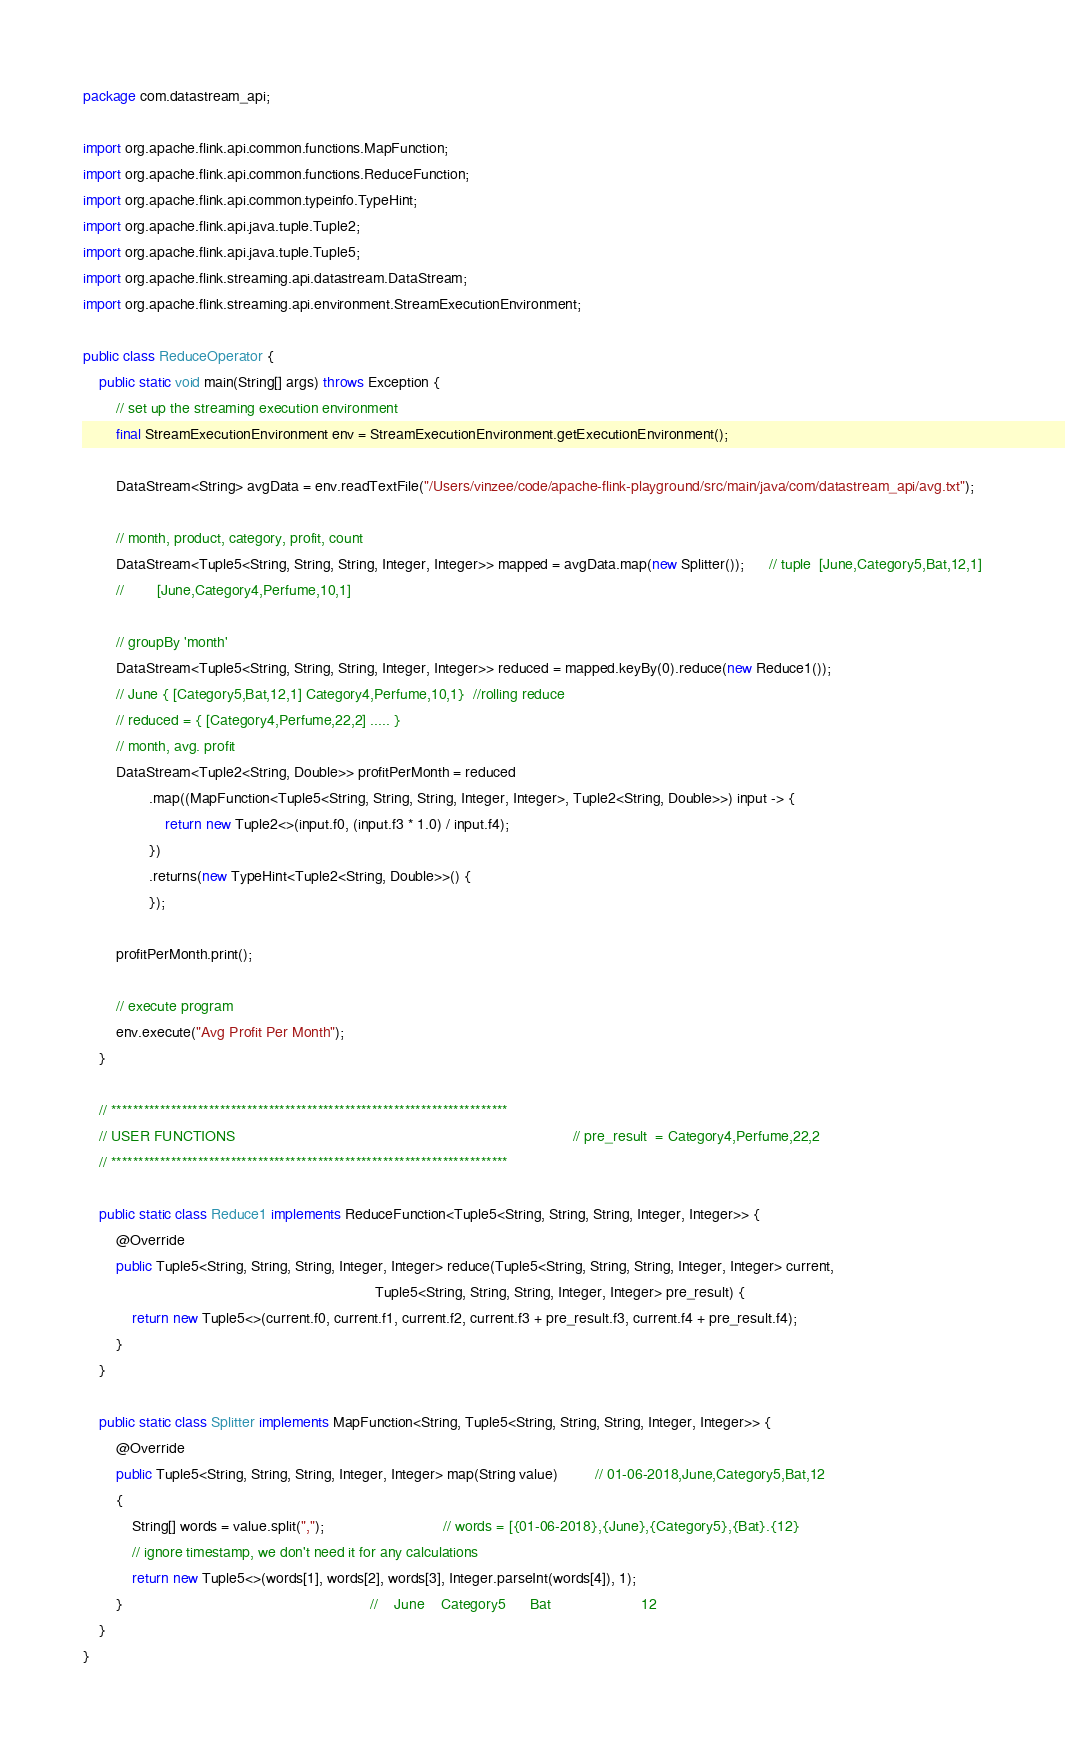Convert code to text. <code><loc_0><loc_0><loc_500><loc_500><_Java_>package com.datastream_api;

import org.apache.flink.api.common.functions.MapFunction;
import org.apache.flink.api.common.functions.ReduceFunction;
import org.apache.flink.api.common.typeinfo.TypeHint;
import org.apache.flink.api.java.tuple.Tuple2;
import org.apache.flink.api.java.tuple.Tuple5;
import org.apache.flink.streaming.api.datastream.DataStream;
import org.apache.flink.streaming.api.environment.StreamExecutionEnvironment;

public class ReduceOperator {
    public static void main(String[] args) throws Exception {
        // set up the streaming execution environment
        final StreamExecutionEnvironment env = StreamExecutionEnvironment.getExecutionEnvironment();

        DataStream<String> avgData = env.readTextFile("/Users/vinzee/code/apache-flink-playground/src/main/java/com/datastream_api/avg.txt");

        // month, product, category, profit, count
        DataStream<Tuple5<String, String, String, Integer, Integer>> mapped = avgData.map(new Splitter());      // tuple  [June,Category5,Bat,12,1]
        //        [June,Category4,Perfume,10,1]

        // groupBy 'month'
        DataStream<Tuple5<String, String, String, Integer, Integer>> reduced = mapped.keyBy(0).reduce(new Reduce1());
        // June { [Category5,Bat,12,1] Category4,Perfume,10,1}	//rolling reduce
        // reduced = { [Category4,Perfume,22,2] ..... }
        // month, avg. profit
        DataStream<Tuple2<String, Double>> profitPerMonth = reduced
                .map((MapFunction<Tuple5<String, String, String, Integer, Integer>, Tuple2<String, Double>>) input -> {
                    return new Tuple2<>(input.f0, (input.f3 * 1.0) / input.f4);
                })
                .returns(new TypeHint<Tuple2<String, Double>>() {
                });

        profitPerMonth.print();

        // execute program
        env.execute("Avg Profit Per Month");
    }

    // *************************************************************************
    // USER FUNCTIONS                                                                                  // pre_result  = Category4,Perfume,22,2        
    // *************************************************************************

    public static class Reduce1 implements ReduceFunction<Tuple5<String, String, String, Integer, Integer>> {
        @Override
        public Tuple5<String, String, String, Integer, Integer> reduce(Tuple5<String, String, String, Integer, Integer> current,
                                                                       Tuple5<String, String, String, Integer, Integer> pre_result) {
            return new Tuple5<>(current.f0, current.f1, current.f2, current.f3 + pre_result.f3, current.f4 + pre_result.f4);
        }
    }

    public static class Splitter implements MapFunction<String, Tuple5<String, String, String, Integer, Integer>> {
        @Override
        public Tuple5<String, String, String, Integer, Integer> map(String value)         // 01-06-2018,June,Category5,Bat,12
        {
            String[] words = value.split(",");                             // words = [{01-06-2018},{June},{Category5},{Bat}.{12}
            // ignore timestamp, we don't need it for any calculations
            return new Tuple5<>(words[1], words[2], words[3], Integer.parseInt(words[4]), 1);
        }                                                            //    June    Category5      Bat                      12
    }
}
</code> 